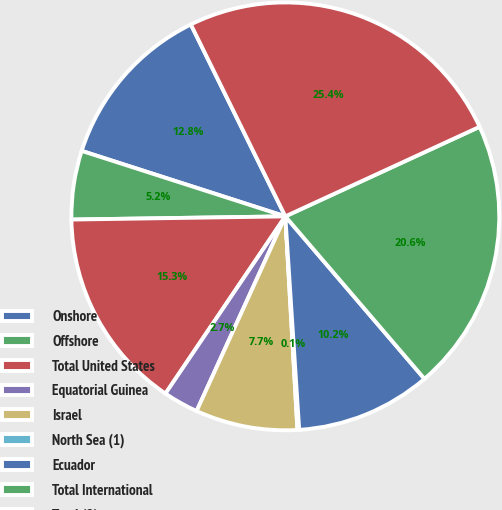<chart> <loc_0><loc_0><loc_500><loc_500><pie_chart><fcel>Onshore<fcel>Offshore<fcel>Total United States<fcel>Equatorial Guinea<fcel>Israel<fcel>North Sea (1)<fcel>Ecuador<fcel>Total International<fcel>Total (2)<nl><fcel>12.77%<fcel>5.19%<fcel>15.3%<fcel>2.66%<fcel>7.71%<fcel>0.13%<fcel>10.24%<fcel>20.61%<fcel>25.41%<nl></chart> 